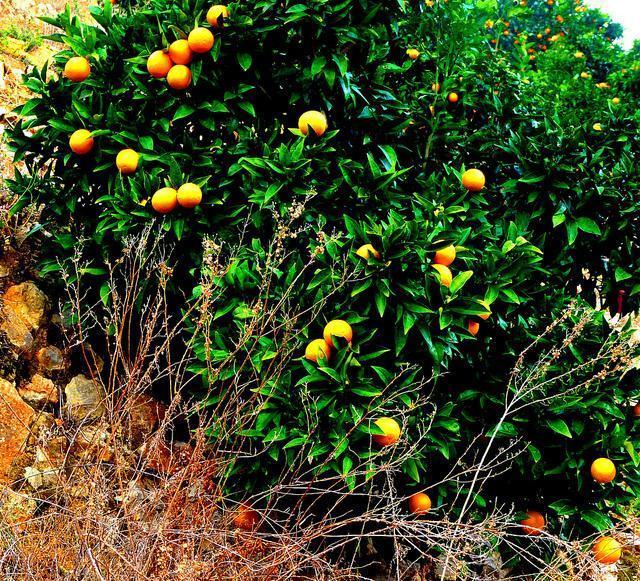How many people are in this photo?
Give a very brief answer. 0. 